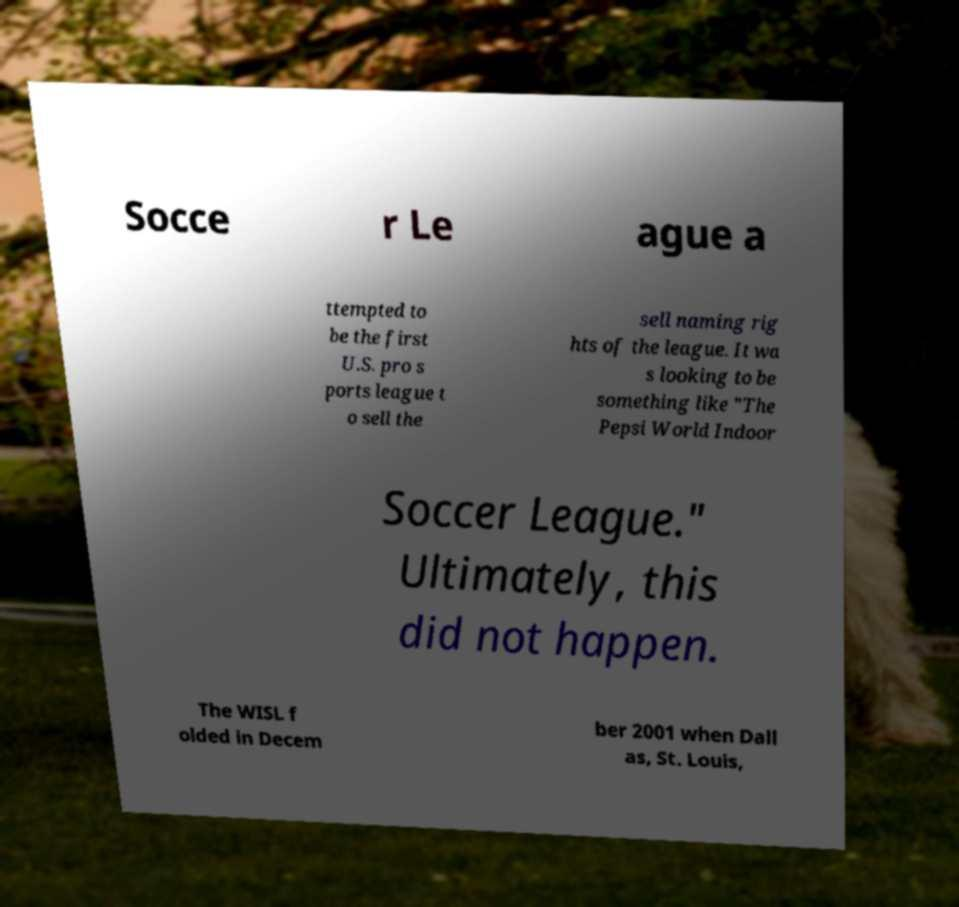I need the written content from this picture converted into text. Can you do that? Socce r Le ague a ttempted to be the first U.S. pro s ports league t o sell the sell naming rig hts of the league. It wa s looking to be something like "The Pepsi World Indoor Soccer League." Ultimately, this did not happen. The WISL f olded in Decem ber 2001 when Dall as, St. Louis, 